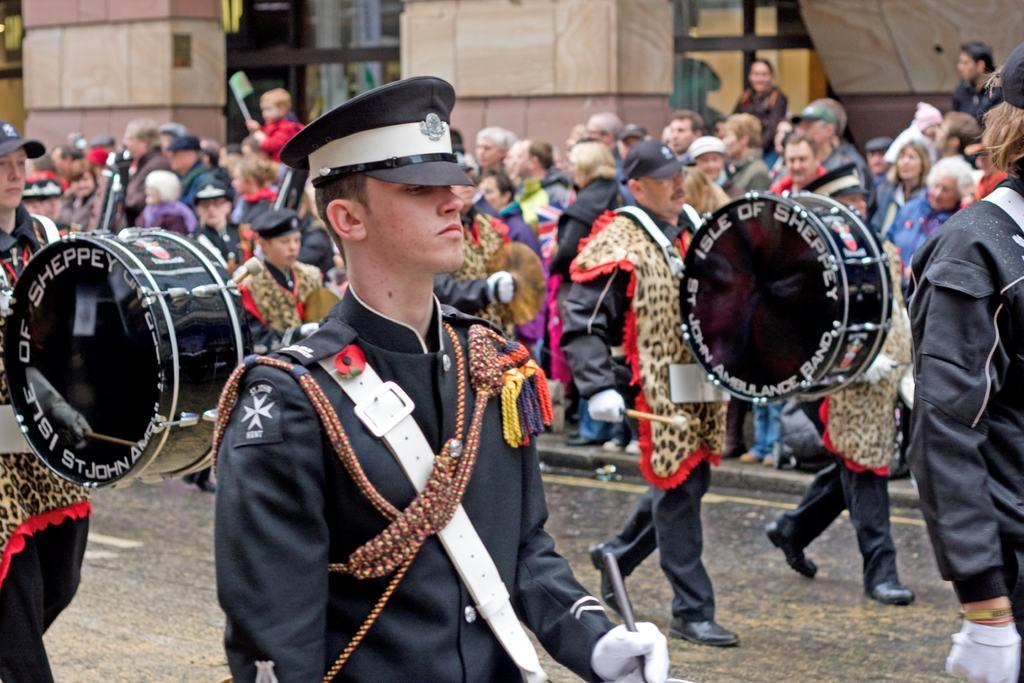What are the men in the image doing? The men in the image are playing drums. What are the men wearing on their heads? The men are wearing caps. Are the men moving or stationary in the image? The men are walking. What can be seen in the background of the image? There is a building and people standing near it in the background. Is there a rainstorm happening in the image? There is no indication of a rainstorm in the image. What type of plants can be seen growing near the building in the background? There is no mention of plants in the image; only the building and people standing near it are visible. 